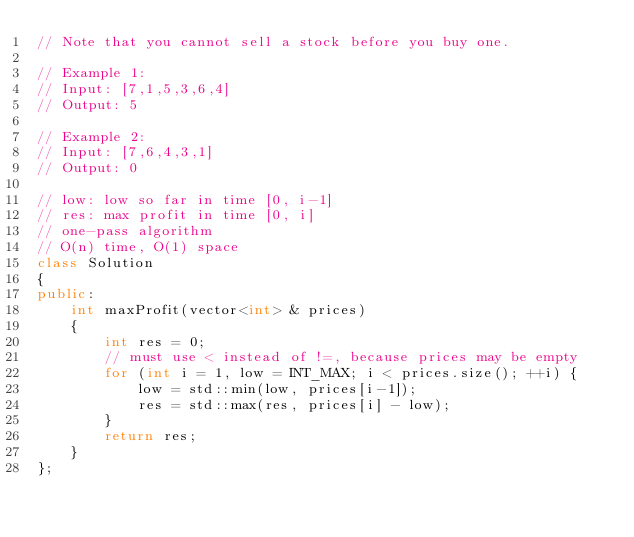<code> <loc_0><loc_0><loc_500><loc_500><_C++_>// Note that you cannot sell a stock before you buy one.

// Example 1:
// Input: [7,1,5,3,6,4]
// Output: 5

// Example 2:
// Input: [7,6,4,3,1]
// Output: 0

// low: low so far in time [0, i-1]
// res: max profit in time [0, i]
// one-pass algorithm
// O(n) time, O(1) space
class Solution
{
public:
    int maxProfit(vector<int> & prices)
    {
        int res = 0;
        // must use < instead of !=, because prices may be empty
        for (int i = 1, low = INT_MAX; i < prices.size(); ++i) {
            low = std::min(low, prices[i-1]);
            res = std::max(res, prices[i] - low);
        }
        return res;
    }
};
</code> 